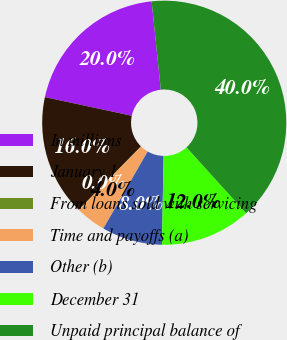<chart> <loc_0><loc_0><loc_500><loc_500><pie_chart><fcel>In millions<fcel>January 1<fcel>From loans sold with servicing<fcel>Time and payoffs (a)<fcel>Other (b)<fcel>December 31<fcel>Unpaid principal balance of<nl><fcel>19.99%<fcel>16.0%<fcel>0.03%<fcel>4.02%<fcel>8.01%<fcel>12.0%<fcel>39.95%<nl></chart> 